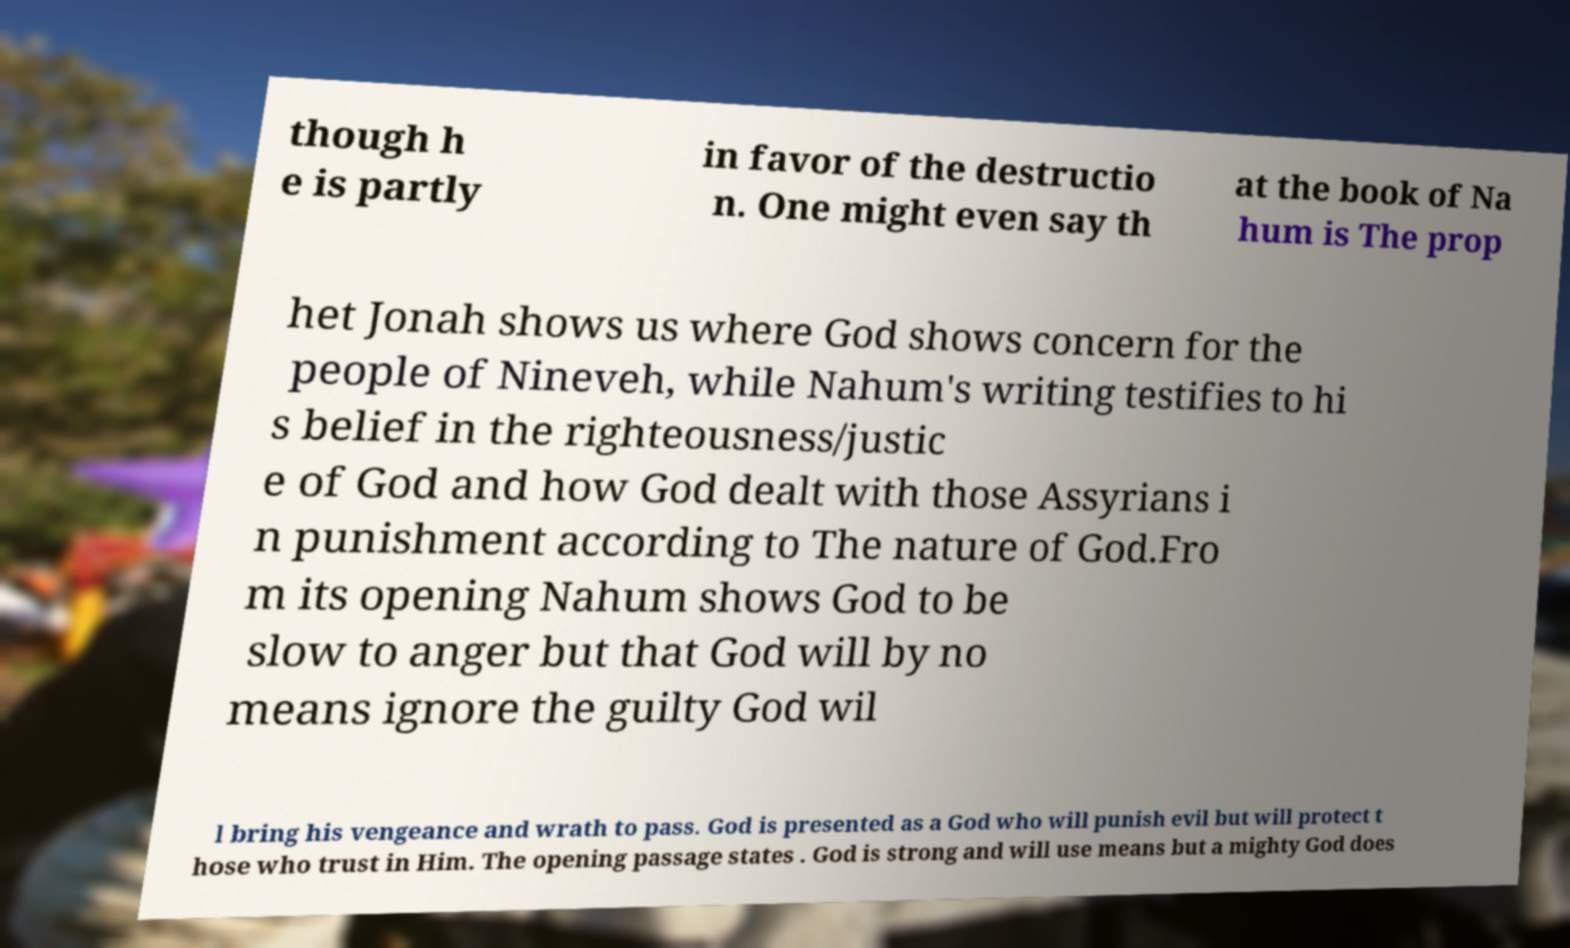What messages or text are displayed in this image? I need them in a readable, typed format. though h e is partly in favor of the destructio n. One might even say th at the book of Na hum is The prop het Jonah shows us where God shows concern for the people of Nineveh, while Nahum's writing testifies to hi s belief in the righteousness/justic e of God and how God dealt with those Assyrians i n punishment according to The nature of God.Fro m its opening Nahum shows God to be slow to anger but that God will by no means ignore the guilty God wil l bring his vengeance and wrath to pass. God is presented as a God who will punish evil but will protect t hose who trust in Him. The opening passage states . God is strong and will use means but a mighty God does 